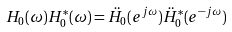<formula> <loc_0><loc_0><loc_500><loc_500>H _ { 0 } ( \omega ) H _ { 0 } ^ { * } ( \omega ) = \ddot { H } _ { 0 } ( e ^ { j \omega } ) \ddot { H } _ { 0 } ^ { * } ( e ^ { - j \omega } )</formula> 